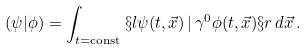Convert formula to latex. <formula><loc_0><loc_0><loc_500><loc_500>( \psi | \phi ) = \int _ { t = \text {const} } \S l \psi ( t , \vec { x } ) \, | \, \gamma ^ { 0 } \phi ( t , \vec { x } ) \S r \, d \vec { x } \, .</formula> 